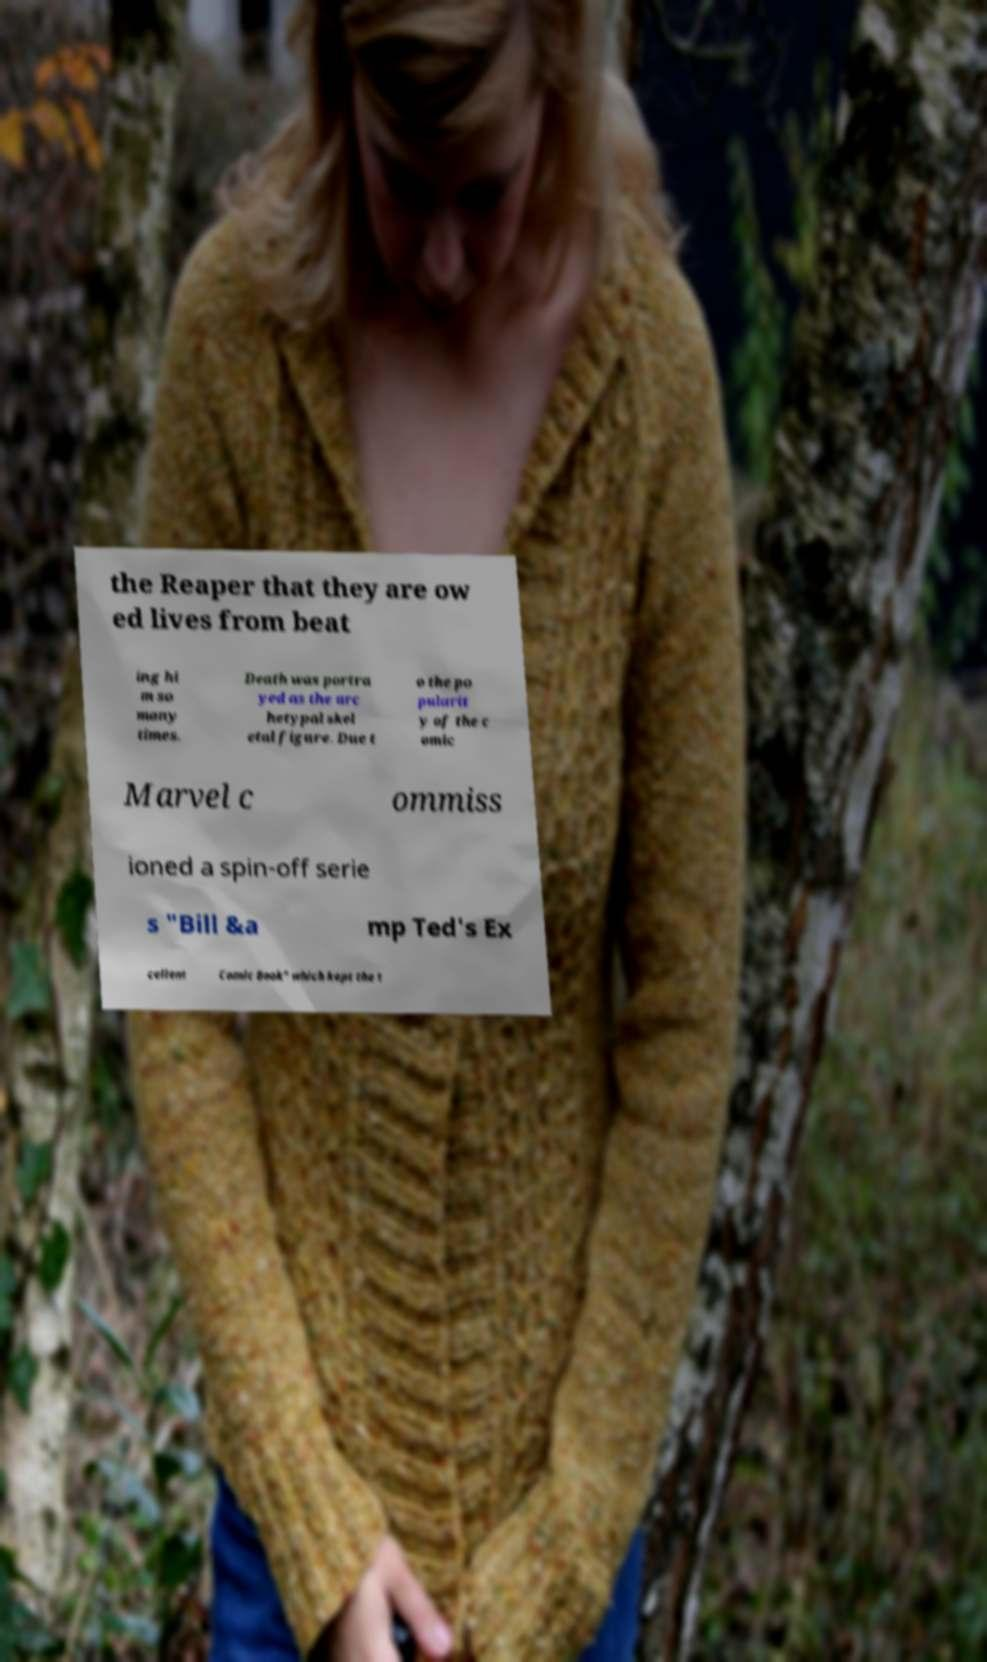For documentation purposes, I need the text within this image transcribed. Could you provide that? the Reaper that they are ow ed lives from beat ing hi m so many times. Death was portra yed as the arc hetypal skel etal figure. Due t o the po pularit y of the c omic Marvel c ommiss ioned a spin-off serie s "Bill &a mp Ted's Ex cellent Comic Book" which kept the t 